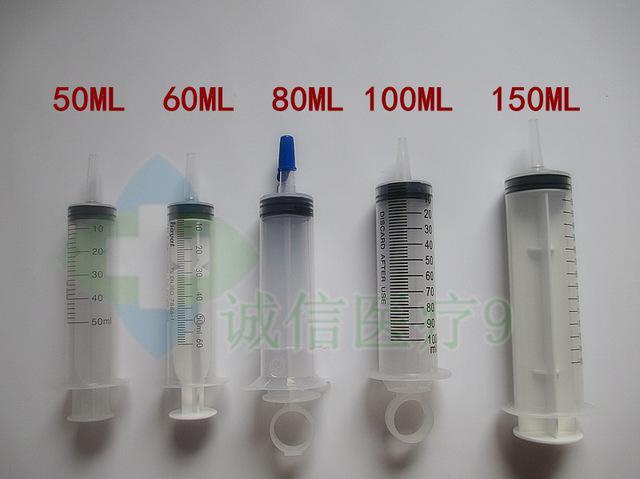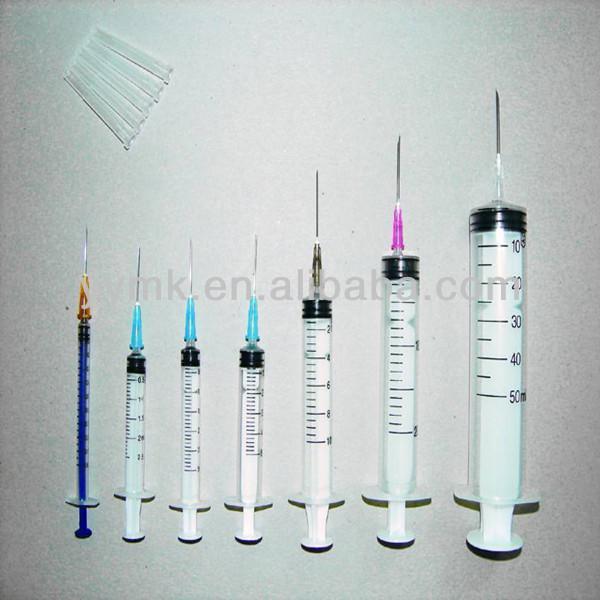The first image is the image on the left, the second image is the image on the right. Examine the images to the left and right. Is the description "In at least one image there are at least five syringes with one having a circle that is used to press the liquid out." accurate? Answer yes or no. Yes. The first image is the image on the left, the second image is the image on the right. Given the left and right images, does the statement "One of the images shows only one syringe, and it has a ring on the end of it." hold true? Answer yes or no. No. 